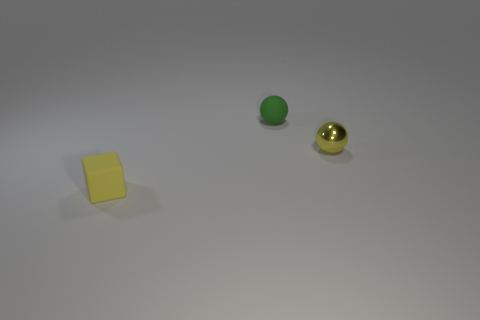Is the number of small rubber things to the right of the yellow block greater than the number of cubes?
Give a very brief answer. No. There is a tiny yellow thing behind the block; is it the same shape as the tiny yellow rubber object?
Provide a short and direct response. No. Is there any other thing that is the same material as the small yellow sphere?
Offer a terse response. No. How many objects are either tiny rubber objects or tiny yellow objects to the right of the small block?
Ensure brevity in your answer.  3. How big is the object that is both on the right side of the rubber block and in front of the small green sphere?
Ensure brevity in your answer.  Small. Is the number of things that are in front of the small green object greater than the number of small yellow spheres that are in front of the small metallic object?
Ensure brevity in your answer.  Yes. There is a green thing; does it have the same shape as the matte thing that is in front of the tiny green ball?
Offer a very short reply. No. How many other objects are the same shape as the yellow matte object?
Your response must be concise. 0. What color is the tiny object that is both in front of the green rubber ball and to the left of the yellow metal ball?
Provide a succinct answer. Yellow. What is the color of the rubber sphere?
Offer a terse response. Green. 